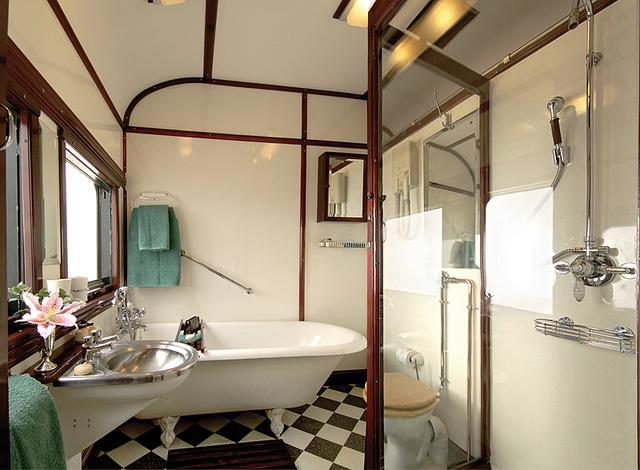What color are the towels?
Keep it brief. Green. Is the floor a solid color?
Write a very short answer. No. Is the flower real?
Concise answer only. Yes. 